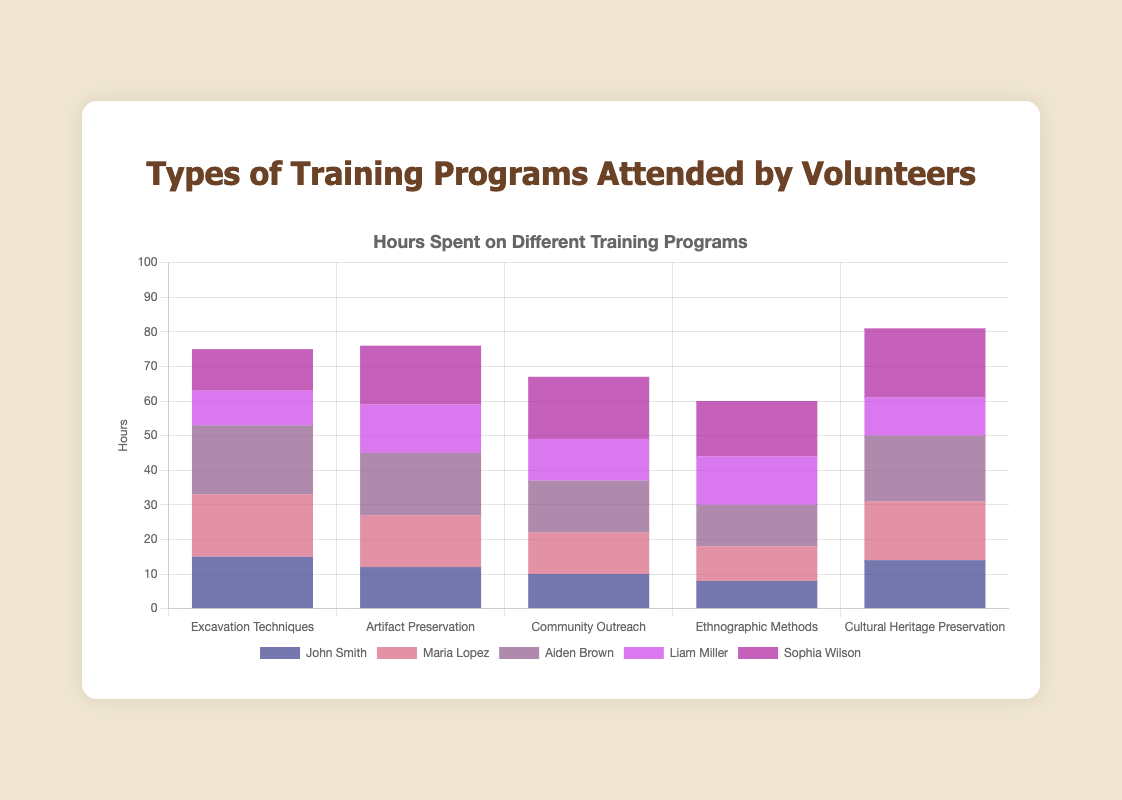Which volunteer spent the most hours on Excavation Techniques? By looking at the bars representing Excavation Techniques for each volunteer, we identify that Aiden Brown's bar is the longest with 20 hours.
Answer: Aiden Brown How many more hours did Sophia Wilson spend on Cultural Heritage Preservation compared to Liam Miller? First, we check the bars for Sophia Wilson and Liam Miller under Cultural Heritage Preservation. Sophia spent 20 hours and Liam spent 11 hours. The difference is 20 - 11.
Answer: 9 What is the total number of hours John Smith spent on all training programs combined? We sum the hours John Smith spent on all the programs: 15 (Excavation Techniques) + 12 (Artifact Preservation) + 10 (Community Outreach) + 8 (Ethnographic Methods) + 14 (Cultural Heritage Preservation).
Answer: 59 Who attended the least number of hours for Ethnographic Methods? Checking the bars for Ethnographic Methods, John Smith's bar is the shortest with 8 hours.
Answer: John Smith Which training program had the highest overall attendance (sum of hours by all volunteers)? We sum the hours for each program:
Excavation Techniques: 15 + 18 + 20 + 10 + 12 = 75
Artifact Preservation: 12 + 15 + 18 + 14 + 17 = 76
Community Outreach: 10 + 12 + 15 + 12 + 18 = 67
Ethnographic Methods: 8 + 10 + 12 + 14 + 16 = 60
Cultural Heritage Preservation: 14 + 17 + 19 + 11 + 20 = 81. The highest total is 81 for Cultural Heritage Preservation.
Answer: Cultural Heritage Preservation Compare the hours spent by Maria Lopez on Artifact Preservation and Ethnographic Methods. Which did she spend more time on? Comparing the bars for Maria Lopez in the respective categories, she spent 15 hours on Artifact Preservation and 10 hours on Ethnographic Methods.
Answer: Artifact Preservation What is the combined sum of hours spent on Community Outreach by Aiden Brown and Liam Miller? We add the hours spent by Aiden Brown (15) and Liam Miller (12) on Community Outreach.
Answer: 27 Which volunteer spent the most time on Community Outreach? Analyzing the bars for Community Outreach, the tallest bar belongs to Sophia Wilson, who spent 18 hours.
Answer: Sophia Wilson Calculate the average number of hours spent by volunteers on Excavation Techniques. Adding the hours spent by each volunteer on Excavation Techniques gives 15 + 18 + 20 + 10 + 12 = 75 hours. Dividing by the 5 volunteers, the average is 75 / 5.
Answer: 15 